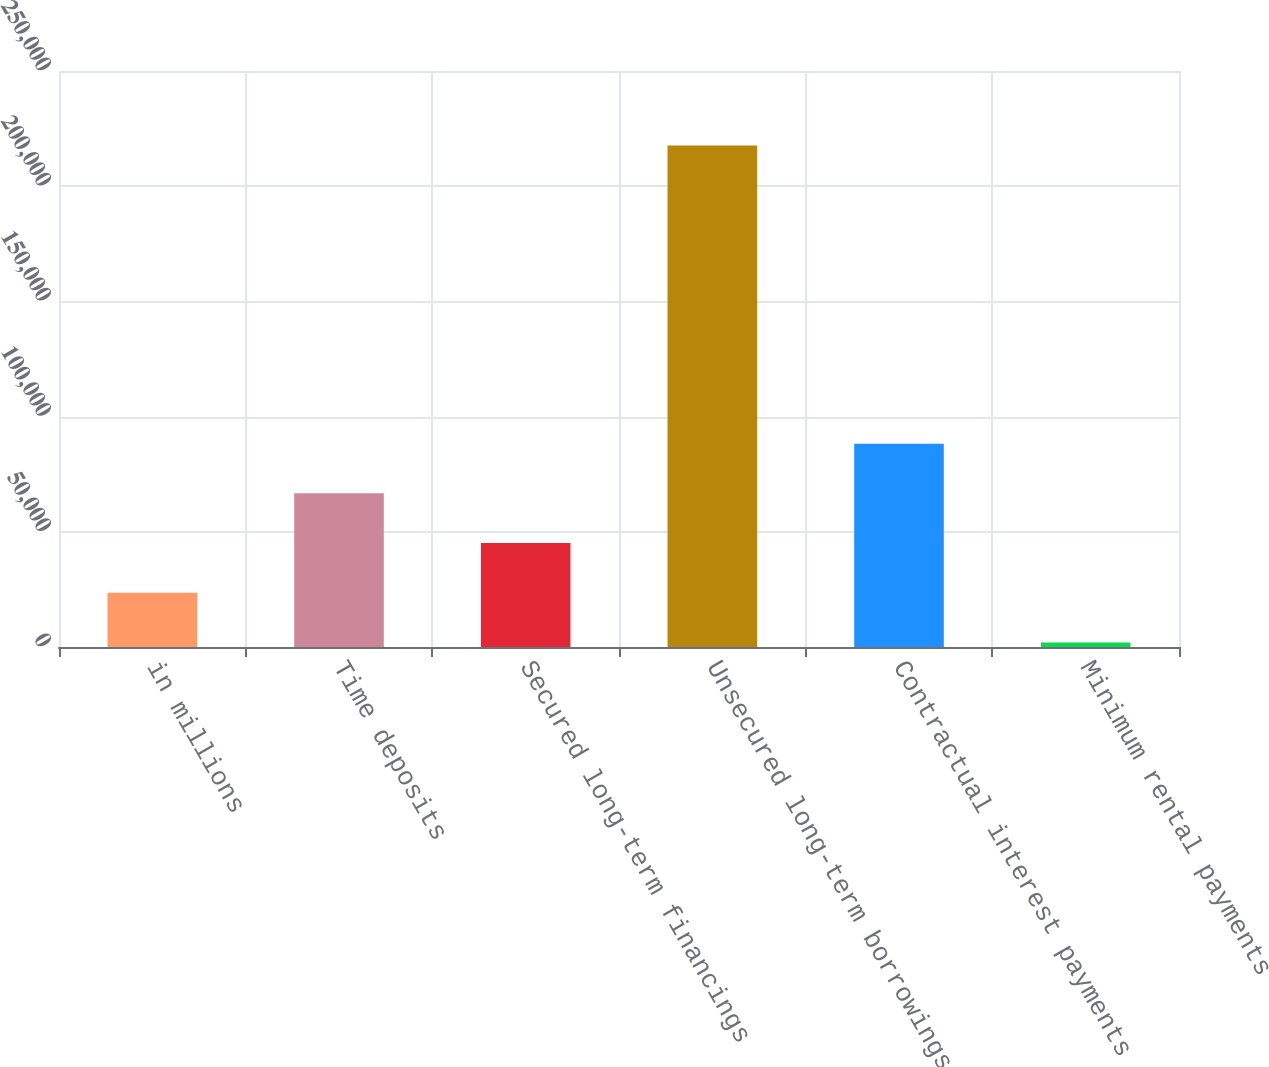Convert chart. <chart><loc_0><loc_0><loc_500><loc_500><bar_chart><fcel>in millions<fcel>Time deposits<fcel>Secured long-term financings<fcel>Unsecured long-term borrowings<fcel>Contractual interest payments<fcel>Minimum rental payments<nl><fcel>23536.3<fcel>66680.9<fcel>45108.6<fcel>217687<fcel>88253.2<fcel>1964<nl></chart> 